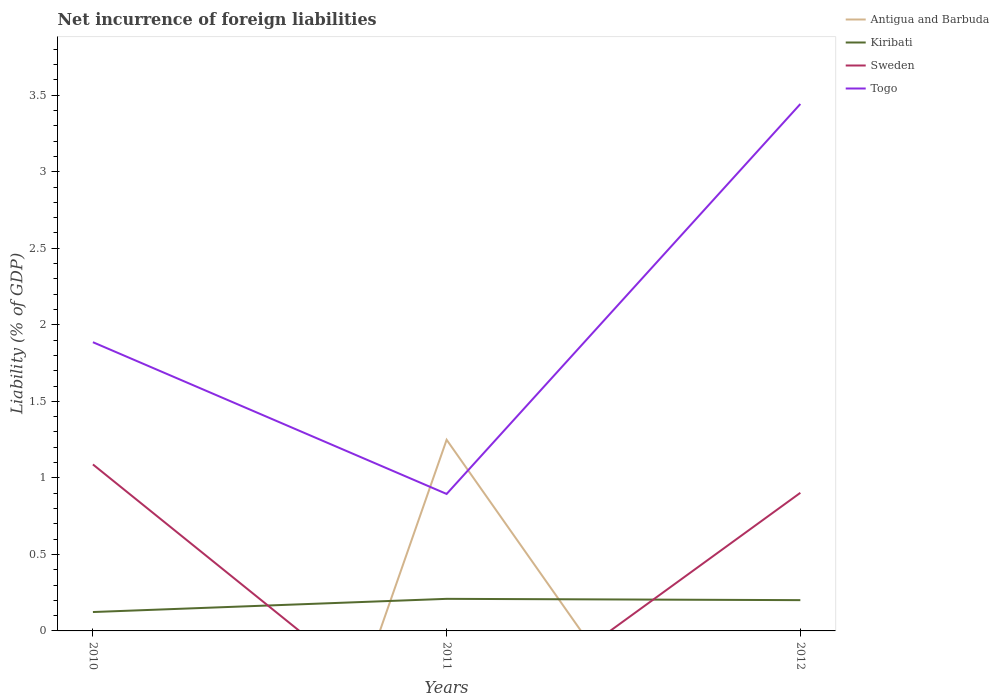Does the line corresponding to Kiribati intersect with the line corresponding to Sweden?
Give a very brief answer. Yes. Is the number of lines equal to the number of legend labels?
Your answer should be compact. No. Across all years, what is the maximum net incurrence of foreign liabilities in Sweden?
Your response must be concise. 0. What is the total net incurrence of foreign liabilities in Kiribati in the graph?
Your answer should be compact. 0.01. What is the difference between the highest and the second highest net incurrence of foreign liabilities in Sweden?
Keep it short and to the point. 1.09. What is the difference between the highest and the lowest net incurrence of foreign liabilities in Antigua and Barbuda?
Ensure brevity in your answer.  1. How many lines are there?
Ensure brevity in your answer.  4. What is the difference between two consecutive major ticks on the Y-axis?
Your response must be concise. 0.5. Are the values on the major ticks of Y-axis written in scientific E-notation?
Your answer should be very brief. No. Does the graph contain grids?
Offer a terse response. No. What is the title of the graph?
Your answer should be compact. Net incurrence of foreign liabilities. What is the label or title of the Y-axis?
Your answer should be very brief. Liability (% of GDP). What is the Liability (% of GDP) in Kiribati in 2010?
Your response must be concise. 0.12. What is the Liability (% of GDP) in Sweden in 2010?
Ensure brevity in your answer.  1.09. What is the Liability (% of GDP) of Togo in 2010?
Make the answer very short. 1.89. What is the Liability (% of GDP) in Antigua and Barbuda in 2011?
Provide a succinct answer. 1.25. What is the Liability (% of GDP) in Kiribati in 2011?
Provide a short and direct response. 0.21. What is the Liability (% of GDP) in Sweden in 2011?
Offer a terse response. 0. What is the Liability (% of GDP) in Togo in 2011?
Provide a short and direct response. 0.89. What is the Liability (% of GDP) in Kiribati in 2012?
Your answer should be very brief. 0.2. What is the Liability (% of GDP) of Sweden in 2012?
Give a very brief answer. 0.9. What is the Liability (% of GDP) in Togo in 2012?
Your answer should be very brief. 3.44. Across all years, what is the maximum Liability (% of GDP) of Antigua and Barbuda?
Provide a succinct answer. 1.25. Across all years, what is the maximum Liability (% of GDP) of Kiribati?
Offer a terse response. 0.21. Across all years, what is the maximum Liability (% of GDP) in Sweden?
Give a very brief answer. 1.09. Across all years, what is the maximum Liability (% of GDP) of Togo?
Provide a succinct answer. 3.44. Across all years, what is the minimum Liability (% of GDP) in Antigua and Barbuda?
Offer a very short reply. 0. Across all years, what is the minimum Liability (% of GDP) in Kiribati?
Ensure brevity in your answer.  0.12. Across all years, what is the minimum Liability (% of GDP) in Sweden?
Provide a short and direct response. 0. Across all years, what is the minimum Liability (% of GDP) in Togo?
Your answer should be compact. 0.89. What is the total Liability (% of GDP) of Antigua and Barbuda in the graph?
Give a very brief answer. 1.25. What is the total Liability (% of GDP) in Kiribati in the graph?
Provide a short and direct response. 0.53. What is the total Liability (% of GDP) of Sweden in the graph?
Your response must be concise. 1.99. What is the total Liability (% of GDP) in Togo in the graph?
Provide a succinct answer. 6.22. What is the difference between the Liability (% of GDP) in Kiribati in 2010 and that in 2011?
Ensure brevity in your answer.  -0.09. What is the difference between the Liability (% of GDP) in Togo in 2010 and that in 2011?
Provide a short and direct response. 0.99. What is the difference between the Liability (% of GDP) in Kiribati in 2010 and that in 2012?
Provide a succinct answer. -0.08. What is the difference between the Liability (% of GDP) in Sweden in 2010 and that in 2012?
Offer a terse response. 0.19. What is the difference between the Liability (% of GDP) in Togo in 2010 and that in 2012?
Your response must be concise. -1.56. What is the difference between the Liability (% of GDP) in Kiribati in 2011 and that in 2012?
Provide a short and direct response. 0.01. What is the difference between the Liability (% of GDP) in Togo in 2011 and that in 2012?
Provide a short and direct response. -2.55. What is the difference between the Liability (% of GDP) in Kiribati in 2010 and the Liability (% of GDP) in Togo in 2011?
Make the answer very short. -0.77. What is the difference between the Liability (% of GDP) of Sweden in 2010 and the Liability (% of GDP) of Togo in 2011?
Ensure brevity in your answer.  0.19. What is the difference between the Liability (% of GDP) in Kiribati in 2010 and the Liability (% of GDP) in Sweden in 2012?
Provide a short and direct response. -0.78. What is the difference between the Liability (% of GDP) in Kiribati in 2010 and the Liability (% of GDP) in Togo in 2012?
Offer a very short reply. -3.32. What is the difference between the Liability (% of GDP) in Sweden in 2010 and the Liability (% of GDP) in Togo in 2012?
Provide a succinct answer. -2.35. What is the difference between the Liability (% of GDP) in Antigua and Barbuda in 2011 and the Liability (% of GDP) in Kiribati in 2012?
Keep it short and to the point. 1.05. What is the difference between the Liability (% of GDP) in Antigua and Barbuda in 2011 and the Liability (% of GDP) in Sweden in 2012?
Provide a short and direct response. 0.35. What is the difference between the Liability (% of GDP) in Antigua and Barbuda in 2011 and the Liability (% of GDP) in Togo in 2012?
Keep it short and to the point. -2.19. What is the difference between the Liability (% of GDP) in Kiribati in 2011 and the Liability (% of GDP) in Sweden in 2012?
Your answer should be very brief. -0.69. What is the difference between the Liability (% of GDP) in Kiribati in 2011 and the Liability (% of GDP) in Togo in 2012?
Give a very brief answer. -3.23. What is the average Liability (% of GDP) in Antigua and Barbuda per year?
Provide a succinct answer. 0.42. What is the average Liability (% of GDP) in Kiribati per year?
Make the answer very short. 0.18. What is the average Liability (% of GDP) in Sweden per year?
Ensure brevity in your answer.  0.66. What is the average Liability (% of GDP) in Togo per year?
Provide a succinct answer. 2.07. In the year 2010, what is the difference between the Liability (% of GDP) of Kiribati and Liability (% of GDP) of Sweden?
Offer a very short reply. -0.96. In the year 2010, what is the difference between the Liability (% of GDP) of Kiribati and Liability (% of GDP) of Togo?
Keep it short and to the point. -1.76. In the year 2010, what is the difference between the Liability (% of GDP) in Sweden and Liability (% of GDP) in Togo?
Keep it short and to the point. -0.8. In the year 2011, what is the difference between the Liability (% of GDP) in Antigua and Barbuda and Liability (% of GDP) in Kiribati?
Your answer should be compact. 1.04. In the year 2011, what is the difference between the Liability (% of GDP) of Antigua and Barbuda and Liability (% of GDP) of Togo?
Ensure brevity in your answer.  0.35. In the year 2011, what is the difference between the Liability (% of GDP) in Kiribati and Liability (% of GDP) in Togo?
Offer a terse response. -0.69. In the year 2012, what is the difference between the Liability (% of GDP) of Kiribati and Liability (% of GDP) of Sweden?
Provide a succinct answer. -0.7. In the year 2012, what is the difference between the Liability (% of GDP) of Kiribati and Liability (% of GDP) of Togo?
Your response must be concise. -3.24. In the year 2012, what is the difference between the Liability (% of GDP) in Sweden and Liability (% of GDP) in Togo?
Offer a terse response. -2.54. What is the ratio of the Liability (% of GDP) in Kiribati in 2010 to that in 2011?
Your answer should be compact. 0.59. What is the ratio of the Liability (% of GDP) of Togo in 2010 to that in 2011?
Your answer should be very brief. 2.11. What is the ratio of the Liability (% of GDP) of Kiribati in 2010 to that in 2012?
Offer a terse response. 0.61. What is the ratio of the Liability (% of GDP) in Sweden in 2010 to that in 2012?
Ensure brevity in your answer.  1.21. What is the ratio of the Liability (% of GDP) in Togo in 2010 to that in 2012?
Make the answer very short. 0.55. What is the ratio of the Liability (% of GDP) in Kiribati in 2011 to that in 2012?
Your response must be concise. 1.04. What is the ratio of the Liability (% of GDP) in Togo in 2011 to that in 2012?
Offer a very short reply. 0.26. What is the difference between the highest and the second highest Liability (% of GDP) in Kiribati?
Your response must be concise. 0.01. What is the difference between the highest and the second highest Liability (% of GDP) of Togo?
Keep it short and to the point. 1.56. What is the difference between the highest and the lowest Liability (% of GDP) in Antigua and Barbuda?
Give a very brief answer. 1.25. What is the difference between the highest and the lowest Liability (% of GDP) in Kiribati?
Offer a very short reply. 0.09. What is the difference between the highest and the lowest Liability (% of GDP) of Sweden?
Your response must be concise. 1.09. What is the difference between the highest and the lowest Liability (% of GDP) in Togo?
Provide a succinct answer. 2.55. 